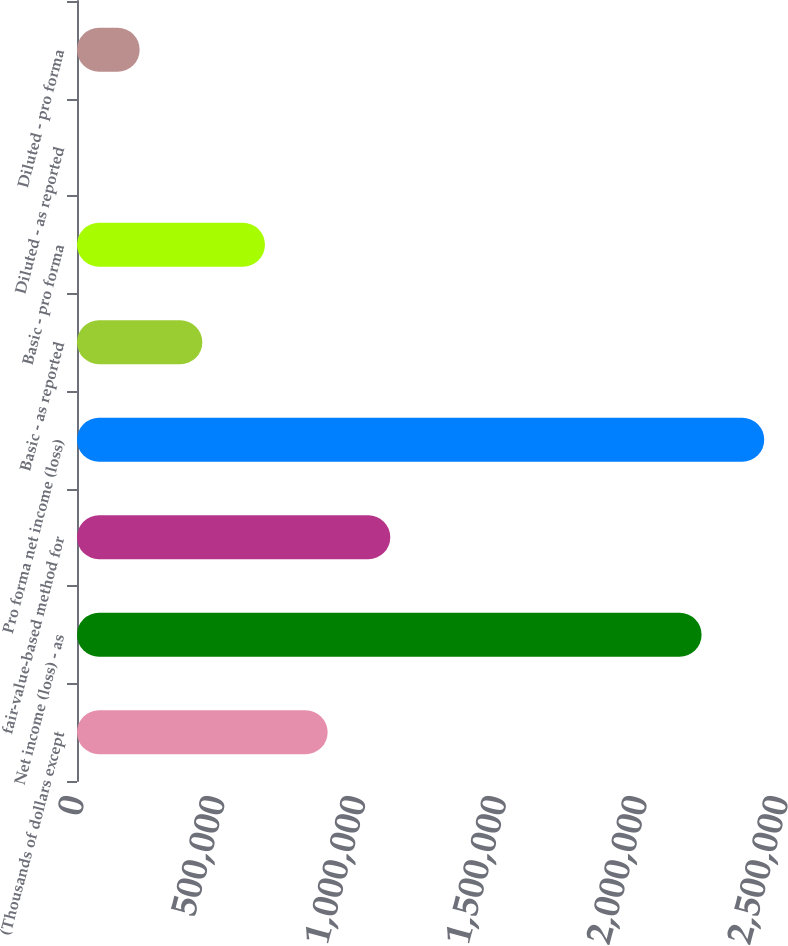Convert chart. <chart><loc_0><loc_0><loc_500><loc_500><bar_chart><fcel>(Thousands of dollars except<fcel>Net income (loss) - as<fcel>fair-value-based method for<fcel>Pro forma net income (loss)<fcel>Basic - as reported<fcel>Basic - pro forma<fcel>Diluted - as reported<fcel>Diluted - pro forma<nl><fcel>889983<fcel>2.21799e+06<fcel>1.11248e+06<fcel>2.44049e+06<fcel>444995<fcel>667489<fcel>5.77<fcel>222500<nl></chart> 